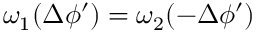<formula> <loc_0><loc_0><loc_500><loc_500>\omega _ { 1 } ( \Delta \phi ^ { \prime } ) = \omega _ { 2 } ( - \Delta \phi ^ { \prime } )</formula> 